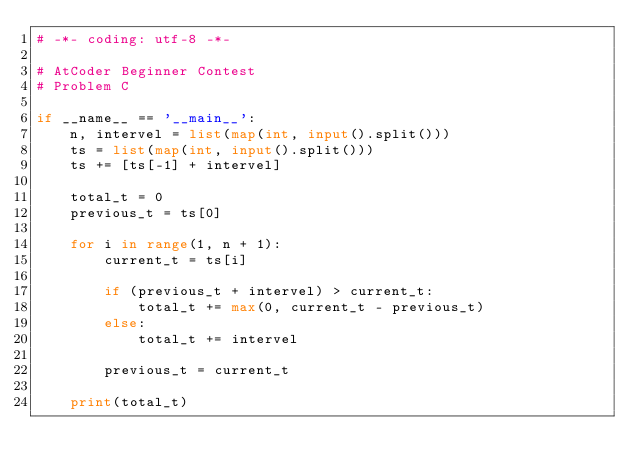Convert code to text. <code><loc_0><loc_0><loc_500><loc_500><_Python_># -*- coding: utf-8 -*-

# AtCoder Beginner Contest
# Problem C

if __name__ == '__main__':
    n, intervel = list(map(int, input().split()))
    ts = list(map(int, input().split()))
    ts += [ts[-1] + intervel]

    total_t = 0
    previous_t = ts[0]

    for i in range(1, n + 1):
        current_t = ts[i]

        if (previous_t + intervel) > current_t:
            total_t += max(0, current_t - previous_t)
        else:
            total_t += intervel

        previous_t = current_t

    print(total_t)
</code> 